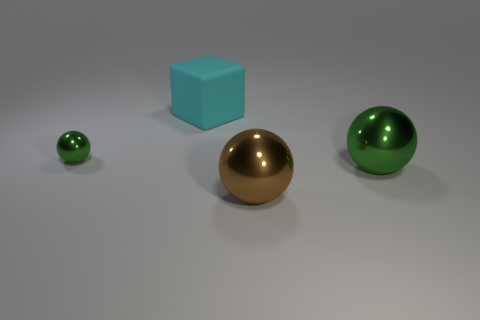Add 2 small green cylinders. How many objects exist? 6 Subtract 0 purple cylinders. How many objects are left? 4 Subtract all cubes. How many objects are left? 3 Subtract 1 blocks. How many blocks are left? 0 Subtract all green blocks. Subtract all brown balls. How many blocks are left? 1 Subtract all cyan spheres. How many red cubes are left? 0 Subtract all metal balls. Subtract all big brown shiny balls. How many objects are left? 0 Add 4 big cyan cubes. How many big cyan cubes are left? 5 Add 1 small green balls. How many small green balls exist? 2 Subtract all green balls. How many balls are left? 1 